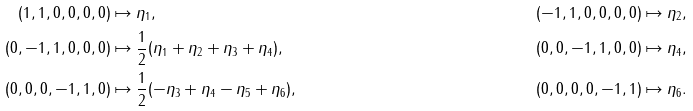<formula> <loc_0><loc_0><loc_500><loc_500>( 1 , 1 , 0 , 0 , 0 , 0 ) & \mapsto \eta _ { 1 } , & & ( - 1 , 1 , 0 , 0 , 0 , 0 ) \mapsto \eta _ { 2 } , \\ ( 0 , - 1 , 1 , 0 , 0 , 0 ) & \mapsto \frac { 1 } 2 ( \eta _ { 1 } + \eta _ { 2 } + \eta _ { 3 } + \eta _ { 4 } ) , & & ( 0 , 0 , - 1 , 1 , 0 , 0 ) \mapsto \eta _ { 4 } , \\ ( 0 , 0 , 0 , - 1 , 1 , 0 ) & \mapsto \frac { 1 } 2 ( - \eta _ { 3 } + \eta _ { 4 } - \eta _ { 5 } + \eta _ { 6 } ) , & & ( 0 , 0 , 0 , 0 , - 1 , 1 ) \mapsto \eta _ { 6 } .</formula> 